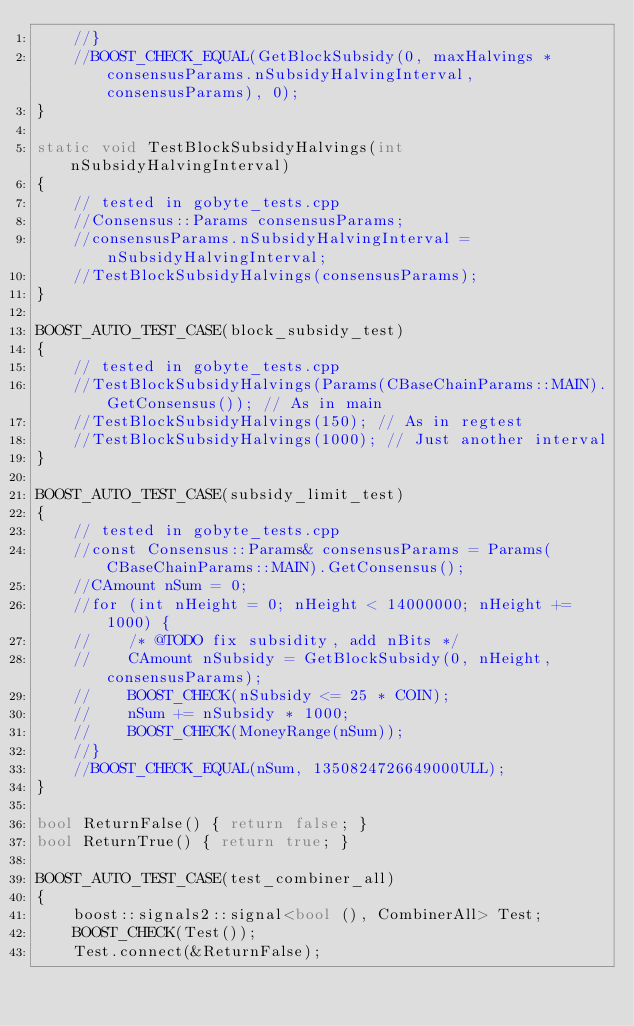<code> <loc_0><loc_0><loc_500><loc_500><_C++_>    //}
    //BOOST_CHECK_EQUAL(GetBlockSubsidy(0, maxHalvings * consensusParams.nSubsidyHalvingInterval, consensusParams), 0);
}

static void TestBlockSubsidyHalvings(int nSubsidyHalvingInterval)
{
    // tested in gobyte_tests.cpp
    //Consensus::Params consensusParams;
    //consensusParams.nSubsidyHalvingInterval = nSubsidyHalvingInterval;
    //TestBlockSubsidyHalvings(consensusParams);
}

BOOST_AUTO_TEST_CASE(block_subsidy_test)
{
    // tested in gobyte_tests.cpp
    //TestBlockSubsidyHalvings(Params(CBaseChainParams::MAIN).GetConsensus()); // As in main
    //TestBlockSubsidyHalvings(150); // As in regtest
    //TestBlockSubsidyHalvings(1000); // Just another interval
}

BOOST_AUTO_TEST_CASE(subsidy_limit_test)
{
    // tested in gobyte_tests.cpp
    //const Consensus::Params& consensusParams = Params(CBaseChainParams::MAIN).GetConsensus();
    //CAmount nSum = 0;
    //for (int nHeight = 0; nHeight < 14000000; nHeight += 1000) {
    //    /* @TODO fix subsidity, add nBits */
    //    CAmount nSubsidy = GetBlockSubsidy(0, nHeight, consensusParams);
    //    BOOST_CHECK(nSubsidy <= 25 * COIN);
    //    nSum += nSubsidy * 1000;
    //    BOOST_CHECK(MoneyRange(nSum));
    //}
    //BOOST_CHECK_EQUAL(nSum, 1350824726649000ULL);
}

bool ReturnFalse() { return false; }
bool ReturnTrue() { return true; }

BOOST_AUTO_TEST_CASE(test_combiner_all)
{
    boost::signals2::signal<bool (), CombinerAll> Test;
    BOOST_CHECK(Test());
    Test.connect(&ReturnFalse);</code> 